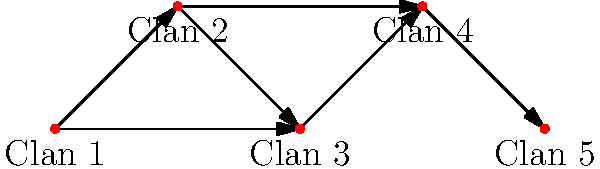In honoring Queen Victoria's interest in Scottish clan territories, you've been tasked with analyzing the connectivity between five clan territories. The diagram represents the territories as nodes, where directed edges indicate possible travel routes between clans. How many different paths can be taken from Clan 1 to Clan 5 without visiting any clan more than once? To solve this problem, we'll use a systematic approach to count the number of paths from Clan 1 to Clan 5:

1. Identify possible paths:
   - Path 1: Clan 1 → Clan 2 → Clan 3 → Clan 4 → Clan 5
   - Path 2: Clan 1 → Clan 2 → Clan 3 → Clan 5
   - Path 3: Clan 1 → Clan 2 → Clan 4 → Clan 5
   - Path 4: Clan 1 → Clan 3 → Clan 4 → Clan 5

2. Verify each path:
   Path 1: Valid (visits each clan once)
   Path 2: Invalid (can't go directly from Clan 3 to Clan 5)
   Path 3: Valid (skips Clan 3)
   Path 4: Valid (skips Clan 2)

3. Count valid paths:
   There are 3 valid paths from Clan 1 to Clan 5 without revisiting any clan.

This analysis respects the historical importance of clan territories and their interconnections, which would be of great interest to a Scottish tour guide and aligns with Queen Victoria's fascination with Scottish heritage.
Answer: 3 paths 